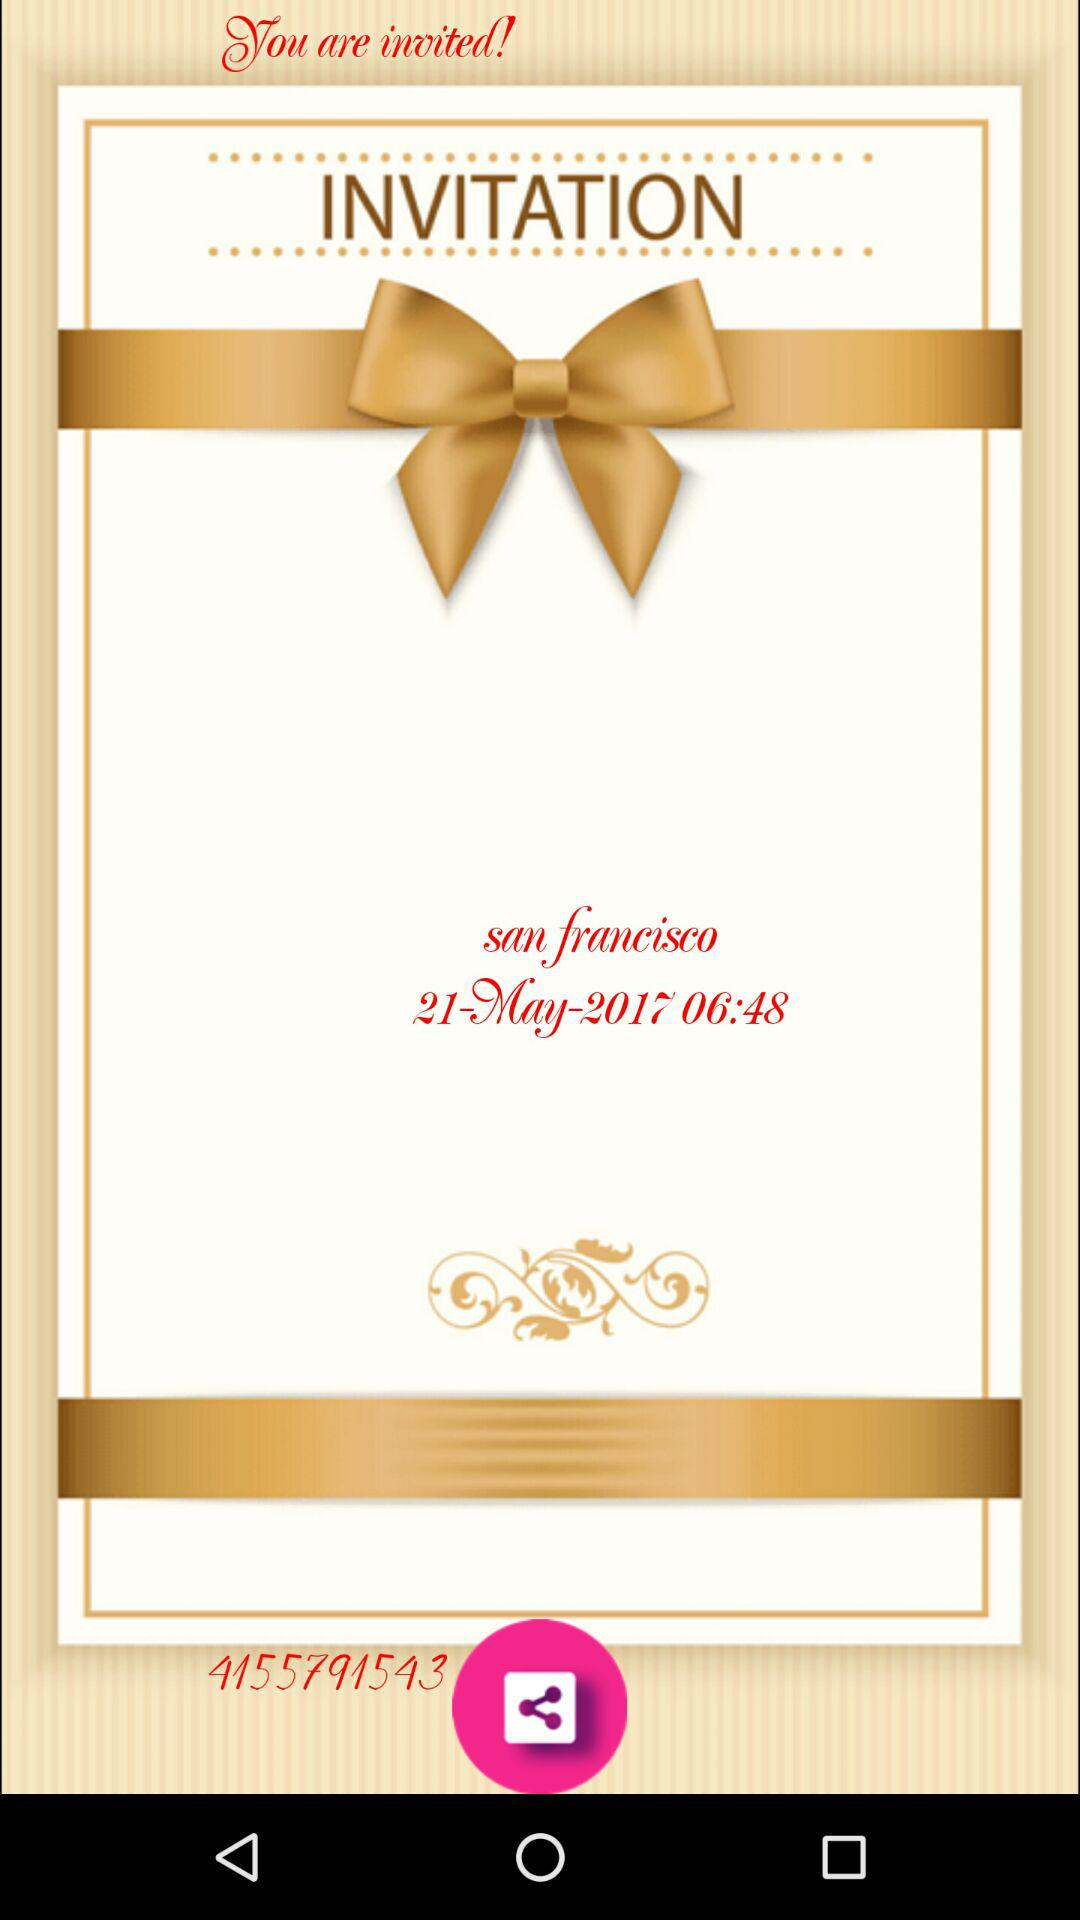What is the time of the invitation? The time of the invitation is 06:48. 